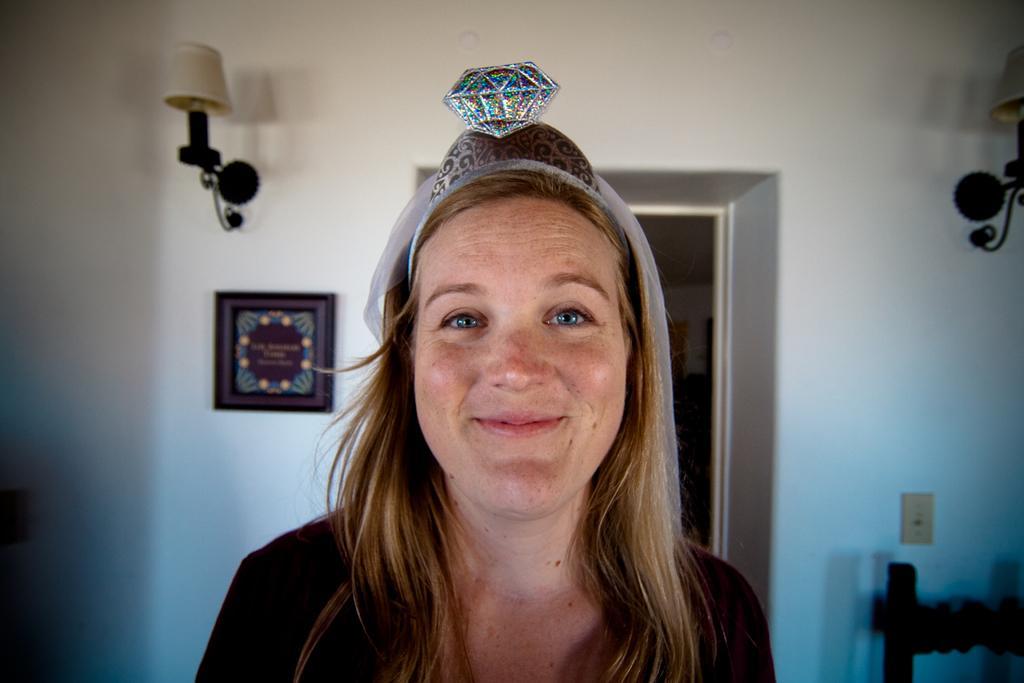How would you summarize this image in a sentence or two? The woman in front of the picture wearing black T-shirt is smiling. She is wearing a hair band and we see a diamond shaped thing is placed on her head. Behind her, we see a white wall on which photo frame and a lamp or lantern or placed. Beside that, we see the entrance of the room. In the right bottom of the picture, we see a chair. 